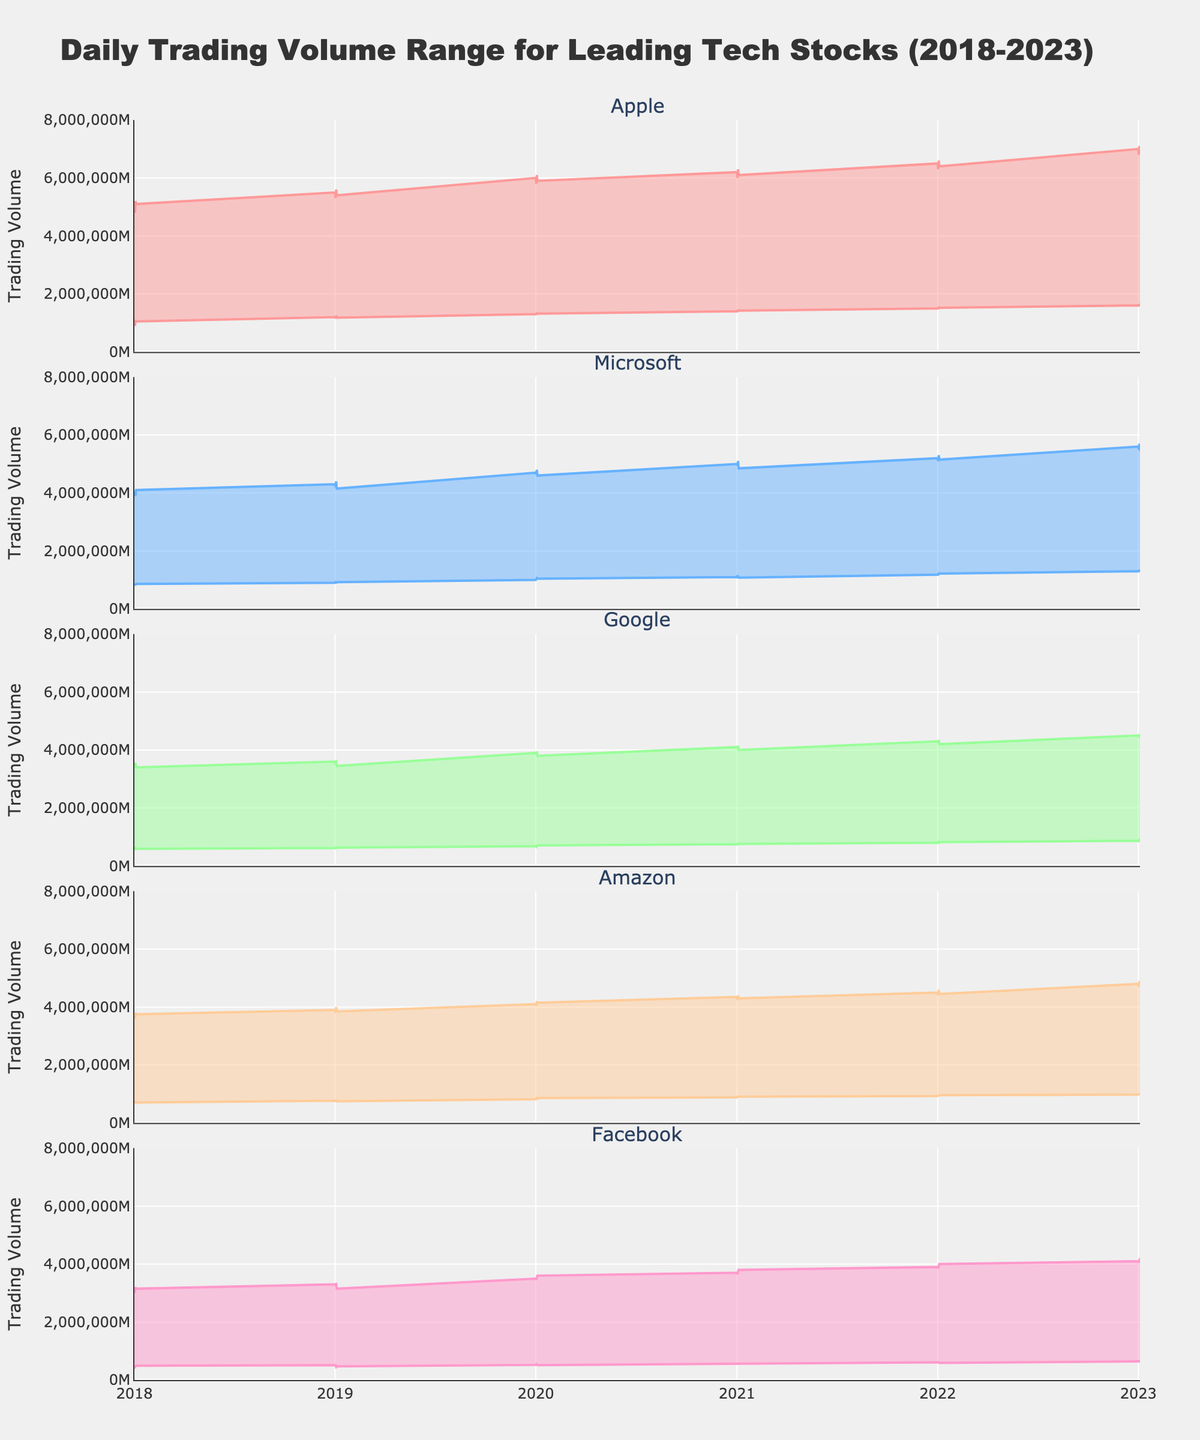What is the title of the chart? The title is displayed at the top of the chart. It provides a summary of what the chart is about.
Answer: Daily Trading Volume Range for Leading Tech Stocks (2018-2023) What are the trading volume ranges for Apple on January 1, 2018? The chart shows two bounds (Min and Max) for each trading volume range. For January 1, 2018, locate the values at the beginning of the range for Apple. The Min value is at the lower boundary and the Max value is at the upper boundary.
Answer: 1,000,000 to 5,000,000 Which company had the highest maximum trading volume in 2023? Identify the peak values for each company's Max range in 2023 by moving along the time axis to the year 2023. Compare the peak values.
Answer: Apple How does Facebook's trading volume range on January 1, 2023 compare to its range on January 1, 2018? Locate the range values for Facebook on January 1, 2023 and January 1, 2018, then compare both the Min and Max values between the two dates.
Answer: 650,000-4,100,000 (2023) higher than 500,000-3,000,000 (2018) Which company's trading volume has shown the most consistent growth over the five years? Analyze the trends over time for each company's Min and Max values. Consistent growth implies a steady increase in both Min and Max values.
Answer: Microsoft What is the average maximum trading volume for Amazon across all years shown? Sum up the maximum trading volumes for Amazon from each year and divide by the number of years. This calculation involves multiple steps: summing the Max values and dividing by count of the years (5 starting points from 2018 to 2023).
Answer: 4,320,000 Which company showed the biggest difference between its minimum and maximum trading volume in 2022 Q4? For Q4 of 2022, find the Min and Max values for each company and calculate the difference (Max - Min). Compare these differences to find the biggest one.
Answer: Amazon How has Google’s trading volume range changed from 2018-2023? Compare Google’s Min and Max values from 2018 to those in 2023 to identify changes in the trading volume range.
Answer: Increased Does any company show a downward trend in maximum trading volume from 2020 to 2023? Look at the Max trading volume values for each company from 2020 to 2023 and observe if any of them demonstrate a decreasing trend.
Answer: None What is the combined minimum trading volume for all companies on January 1, 2021? Sum up the Min trading volumes for Apple, Microsoft, Google, Amazon, and Facebook on January 1, 2021. Basic sum operation is required here.
Answer: 4,590,000 